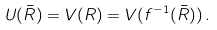Convert formula to latex. <formula><loc_0><loc_0><loc_500><loc_500>U ( \bar { R } ) = V ( R ) = V ( f ^ { - 1 } ( \bar { R } ) ) \, .</formula> 